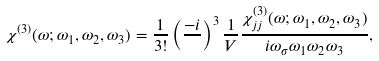Convert formula to latex. <formula><loc_0><loc_0><loc_500><loc_500>\chi ^ { ( 3 ) } ( \omega ; \omega _ { 1 } , \omega _ { 2 } , \omega _ { 3 } ) & = \frac { 1 } { 3 ! } \left ( \frac { - i } { } \right ) ^ { 3 } \frac { 1 } { V } \frac { \chi ^ { ( 3 ) } _ { j j } ( \omega ; \omega _ { 1 } , \omega _ { 2 } , \omega _ { 3 } ) } { i \omega _ { \sigma } \omega _ { 1 } \omega _ { 2 } \omega _ { 3 } } ,</formula> 